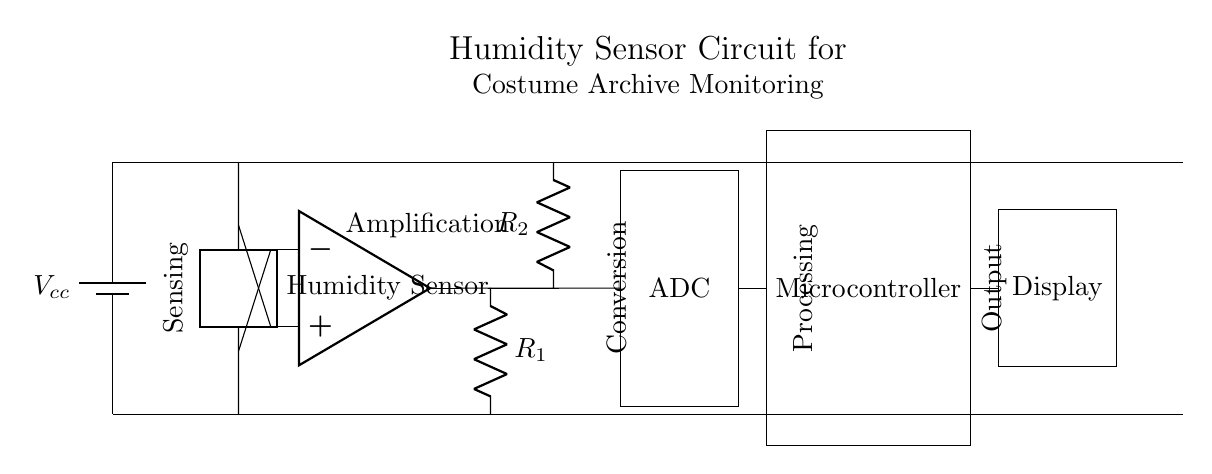What type of circuit is this? This circuit is a humidity sensor circuit designed for monitoring environmental conditions, particularly in costume archives. The main components are a humidity sensor, operational amplifier, ADC, microcontroller, and a display.
Answer: Humidity sensor circuit What does the operational amplifier do in this circuit? The operational amplifier amplifies the signal from the humidity sensor. This is crucial because the output from the sensor may be too weak for further processing, requiring amplification to a usable level for the ADC and microcontroller.
Answer: Amplifies signal How many resistors are present in the circuit? There are two resistors labeled R1 and R2 in this circuit, which are used for setting the gain of the operational amplifier and possibly for other specific functions like filtering.
Answer: Two What component converts the analog signal to a digital signal? The analog-to-digital converter (ADC) is responsible for converting the analog signal from the operational amplifier into a digital signal that the microcontroller can process.
Answer: ADC Where does the power supply connect in the circuit? The power supply connects at the top of the circuit, providing the necessary voltage to power all components. The connections are shown going to the positive terminals and through all components to ensure proper functionality.
Answer: Top of the circuit What is the purpose of the display in this circuit? The display is used for the user to see the humidity readings that are processed by the microcontroller. It provides real-time feedback and alerts regarding the environmental conditions in the costume archive.
Answer: Displays humidity readings What role does the microcontroller play in this circuit? The microcontroller processes the digital signal received from the ADC. It interprets the data, performs necessary computations, and sends the results to the display for monitoring, making it the central processing unit of the circuit.
Answer: Processes data 